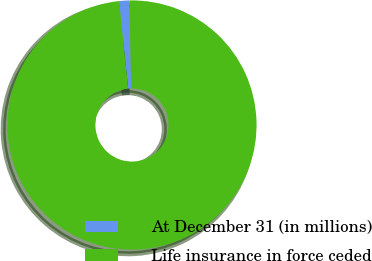Convert chart to OTSL. <chart><loc_0><loc_0><loc_500><loc_500><pie_chart><fcel>At December 31 (in millions)<fcel>Life insurance in force ceded<nl><fcel>1.33%<fcel>98.67%<nl></chart> 